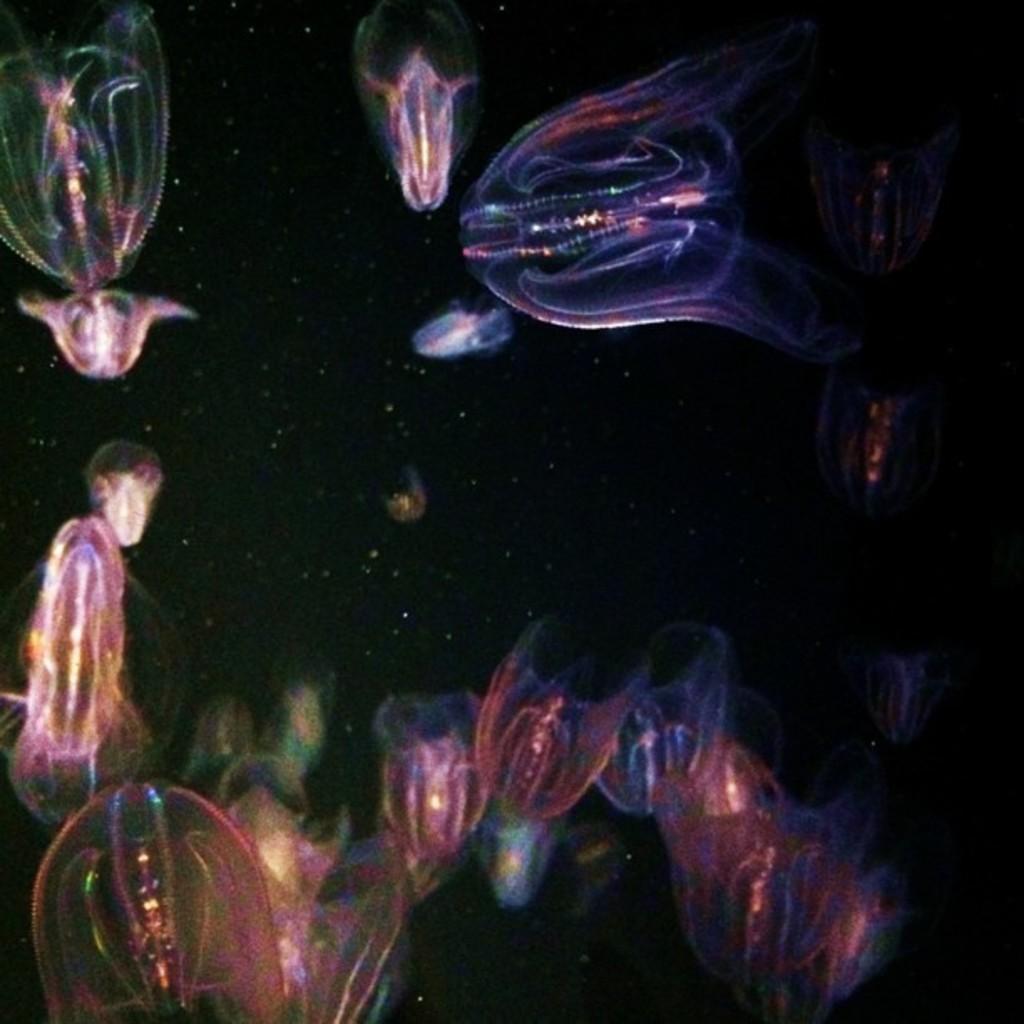Can you describe this image briefly? In this image there are transparent fluorescent jellyfishes in the water. 